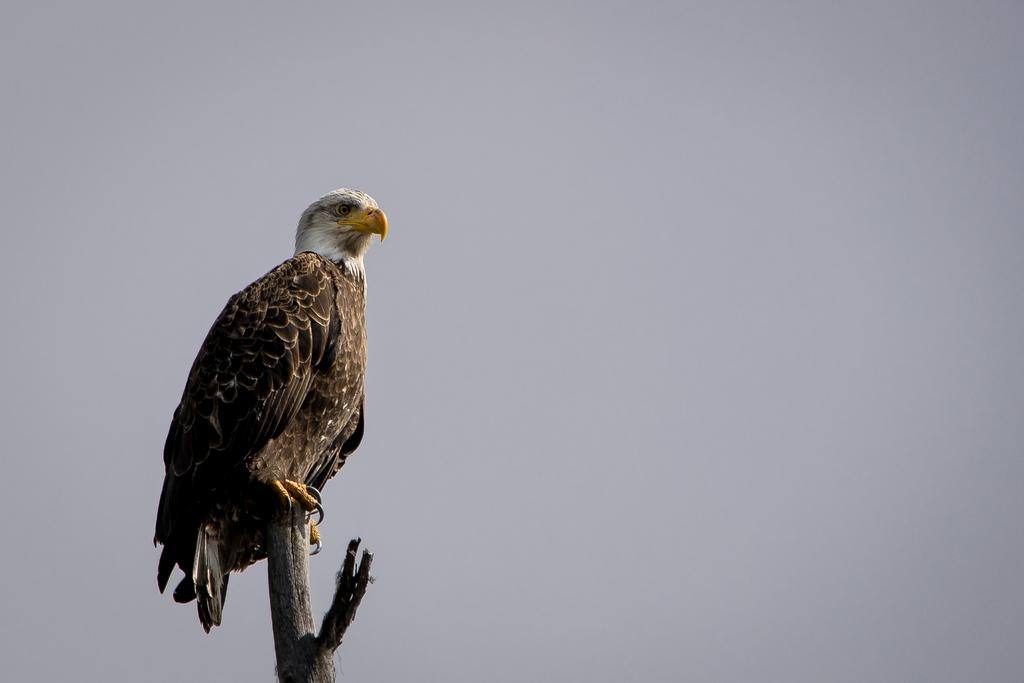What animal is in the image? There is an eagle in the image. What is the eagle doing in the image? The eagle is standing on a branch. What type of lettuce is the eagle offering to the seed in the image? There is no lettuce or seed present in the image; it only features an eagle standing on a branch. 